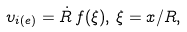<formula> <loc_0><loc_0><loc_500><loc_500>\upsilon _ { i ( e ) } = \dot { R } \, f ( \xi ) , \, \xi = x / R ,</formula> 